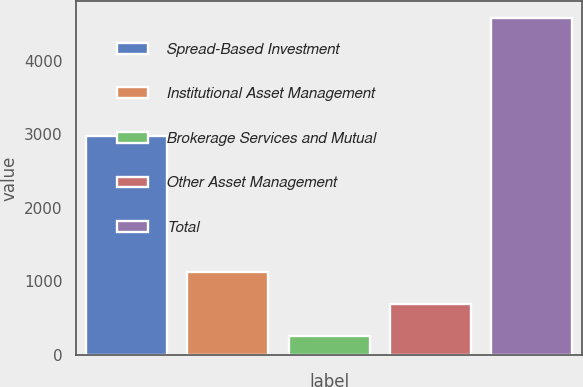<chart> <loc_0><loc_0><loc_500><loc_500><bar_chart><fcel>Spread-Based Investment<fcel>Institutional Asset Management<fcel>Brokerage Services and Mutual<fcel>Other Asset Management<fcel>Total<nl><fcel>2973<fcel>1122<fcel>257<fcel>689.5<fcel>4582<nl></chart> 